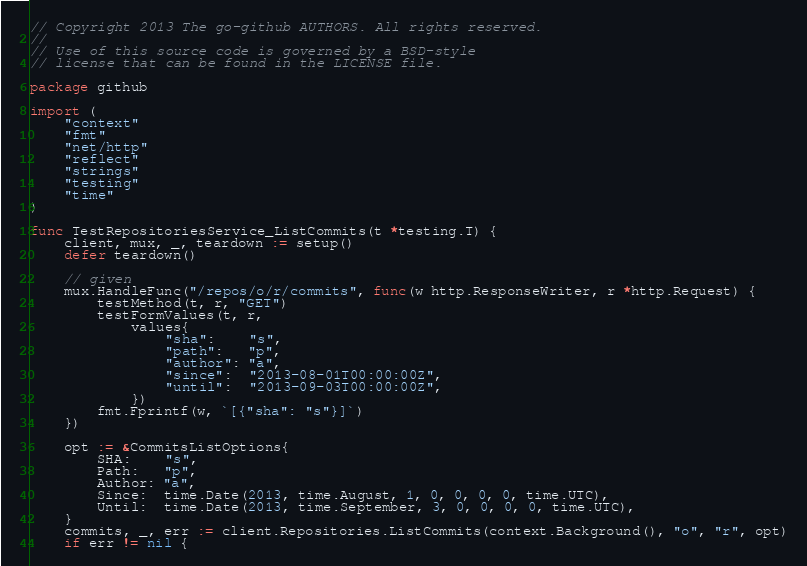<code> <loc_0><loc_0><loc_500><loc_500><_Go_>// Copyright 2013 The go-github AUTHORS. All rights reserved.
//
// Use of this source code is governed by a BSD-style
// license that can be found in the LICENSE file.

package github

import (
	"context"
	"fmt"
	"net/http"
	"reflect"
	"strings"
	"testing"
	"time"
)

func TestRepositoriesService_ListCommits(t *testing.T) {
	client, mux, _, teardown := setup()
	defer teardown()

	// given
	mux.HandleFunc("/repos/o/r/commits", func(w http.ResponseWriter, r *http.Request) {
		testMethod(t, r, "GET")
		testFormValues(t, r,
			values{
				"sha":    "s",
				"path":   "p",
				"author": "a",
				"since":  "2013-08-01T00:00:00Z",
				"until":  "2013-09-03T00:00:00Z",
			})
		fmt.Fprintf(w, `[{"sha": "s"}]`)
	})

	opt := &CommitsListOptions{
		SHA:    "s",
		Path:   "p",
		Author: "a",
		Since:  time.Date(2013, time.August, 1, 0, 0, 0, 0, time.UTC),
		Until:  time.Date(2013, time.September, 3, 0, 0, 0, 0, time.UTC),
	}
	commits, _, err := client.Repositories.ListCommits(context.Background(), "o", "r", opt)
	if err != nil {</code> 